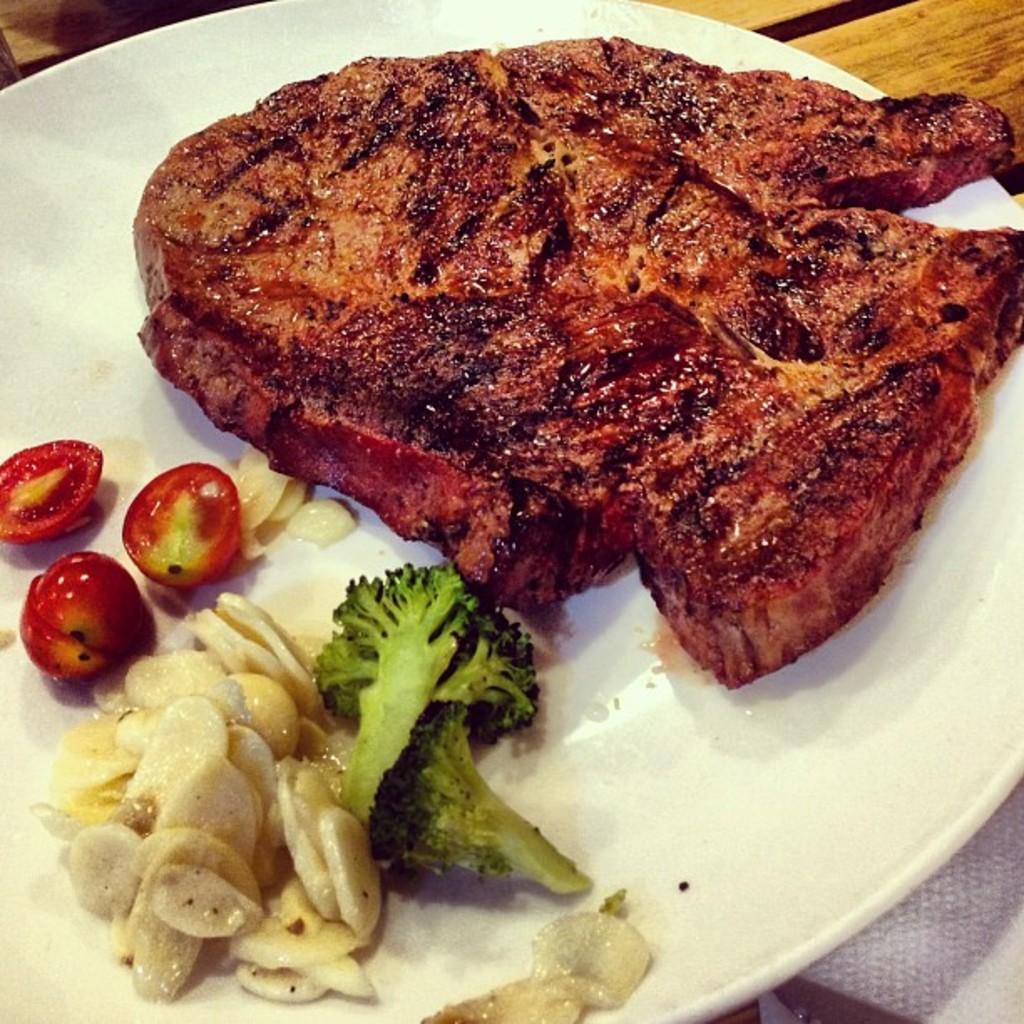Describe this image in one or two sentences. This image consists of a plate, it is in white color. On that there are some eatables, such as tomatoes, broccoli, meat. 